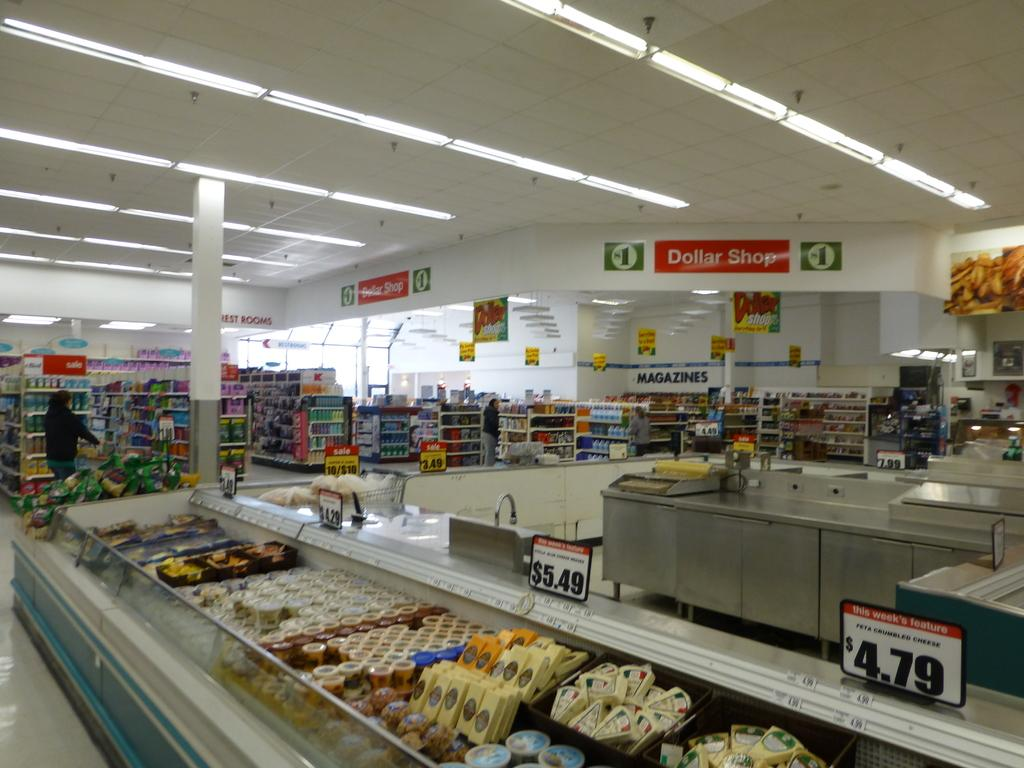<image>
Describe the image concisely. Cheese displayed for $5.49 at the local Dollar Shop 